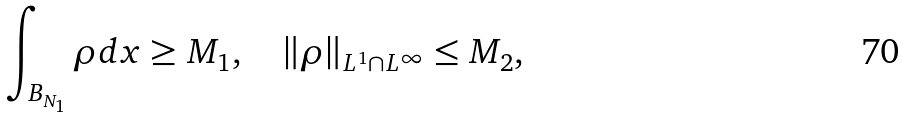Convert formula to latex. <formula><loc_0><loc_0><loc_500><loc_500>\int _ { B _ { N _ { 1 } } } \rho d x \geq M _ { 1 } , \quad \| \rho \| _ { L ^ { 1 } \cap L ^ { \infty } } \leq M _ { 2 } ,</formula> 